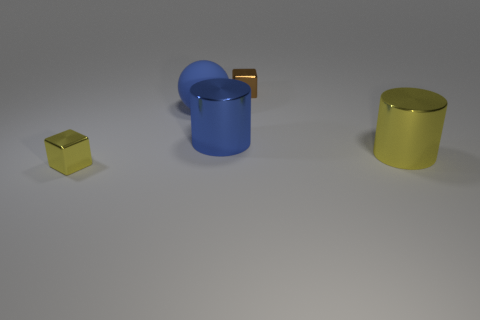What number of other large objects are the same shape as the big blue metal object?
Ensure brevity in your answer.  1. The big shiny thing that is the same color as the large ball is what shape?
Offer a terse response. Cylinder. What is the shape of the small brown thing?
Ensure brevity in your answer.  Cube. There is a yellow metallic object that is to the left of the large rubber object; what size is it?
Provide a succinct answer. Small. The other metal object that is the same size as the brown shiny object is what color?
Provide a succinct answer. Yellow. Is there another large sphere that has the same color as the ball?
Make the answer very short. No. Is the number of yellow metal cubes on the right side of the brown metallic block less than the number of big yellow cylinders that are left of the big blue rubber thing?
Offer a terse response. No. There is a object that is behind the blue shiny object and right of the blue matte sphere; what is its material?
Offer a terse response. Metal. There is a big yellow thing; is it the same shape as the big metallic object that is left of the brown cube?
Ensure brevity in your answer.  Yes. What number of other things are there of the same size as the blue sphere?
Keep it short and to the point. 2. 